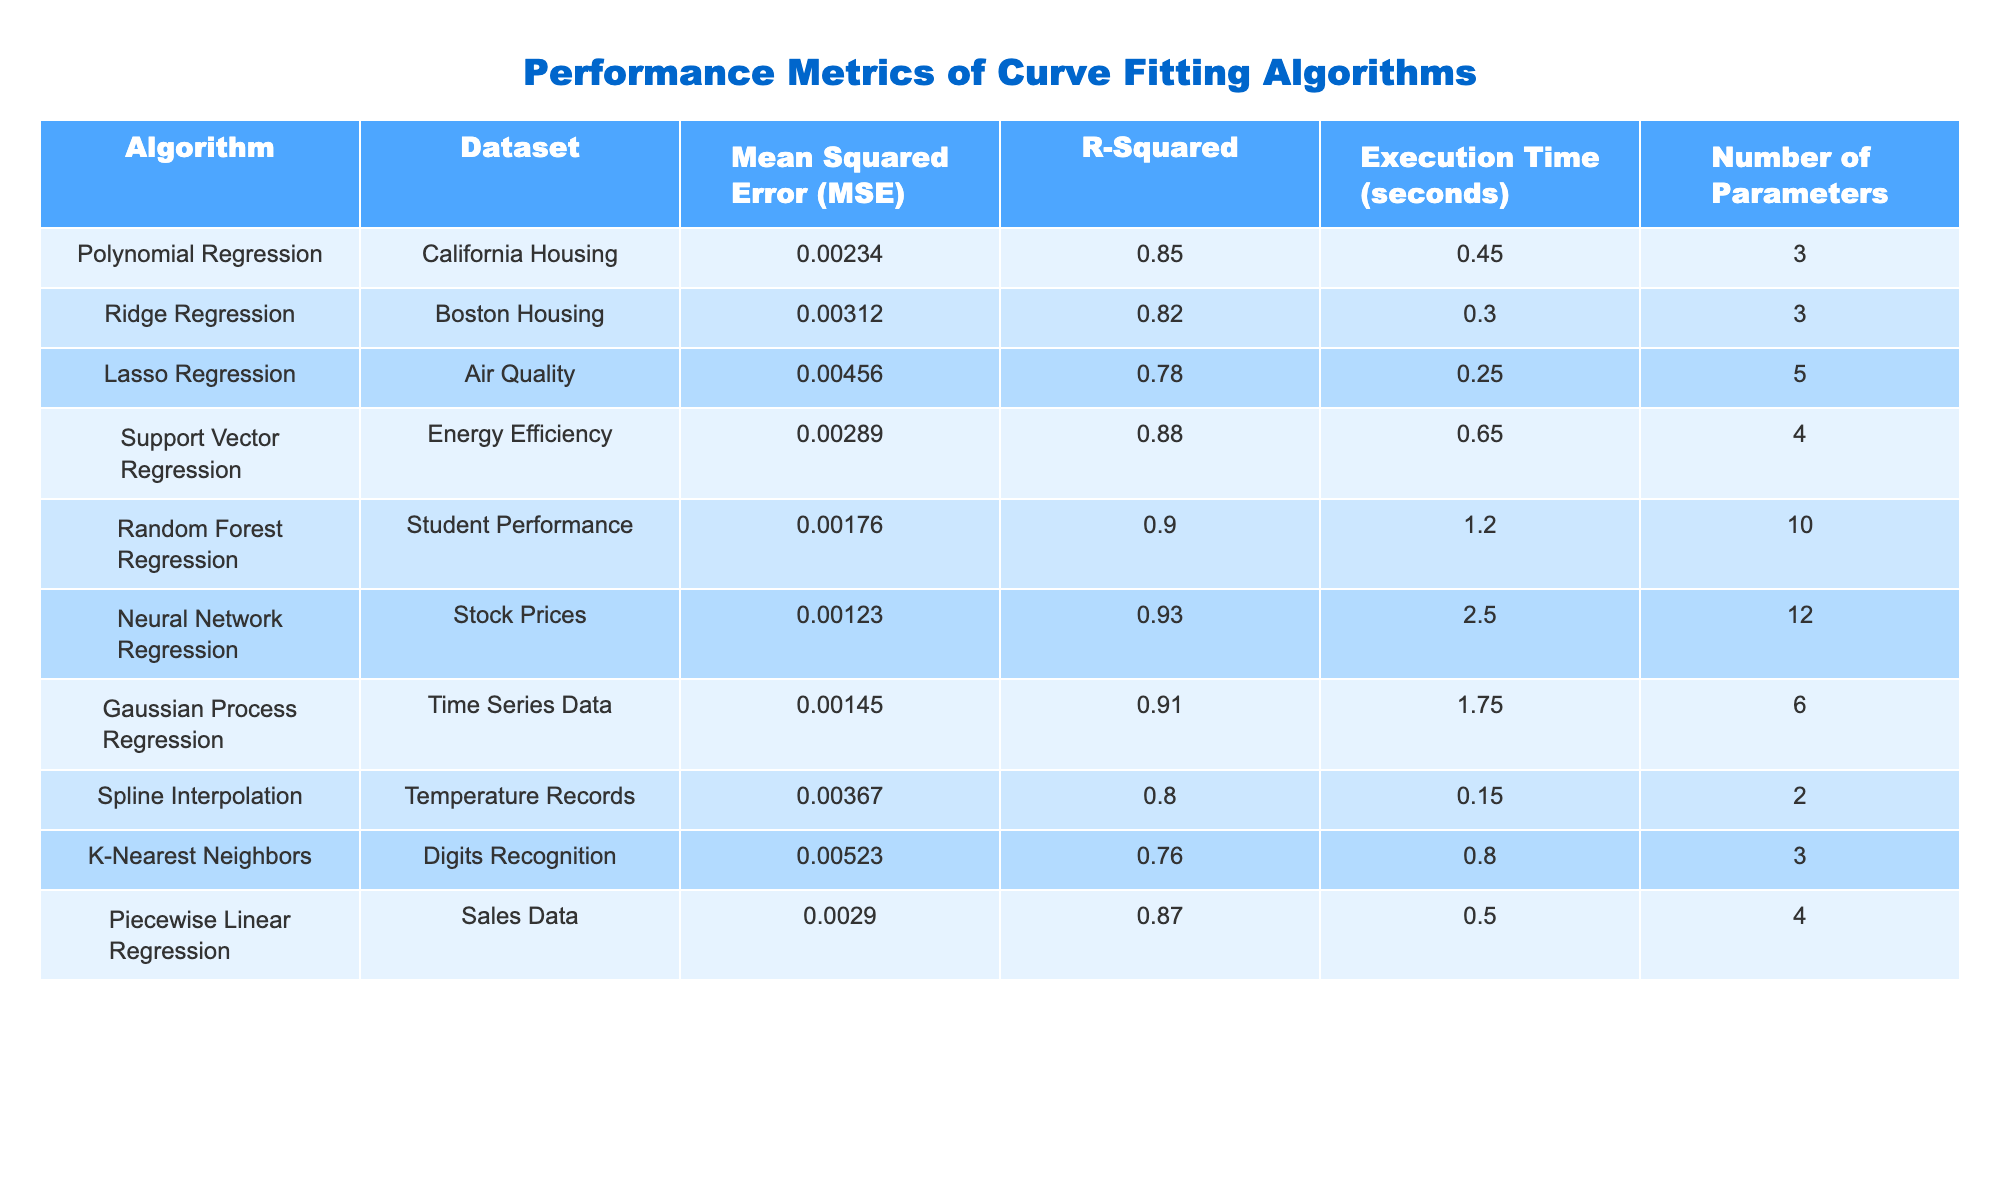What is the Mean Squared Error (MSE) for the Neural Network Regression algorithm? The table lists the MSE values for various algorithms. For Neural Network Regression, the specific value given is 0.00123.
Answer: 0.00123 Which algorithm has the highest R-Squared value? The R-Squared values can be compared across different algorithms. From the table, Neural Network Regression has the highest R-Squared value at 0.93.
Answer: 0.93 Is the execution time for Random Forest Regression greater than that of Lasso Regression? The execution time for Random Forest Regression is 1.20 seconds and for Lasso Regression it is 0.25 seconds. Since 1.20 is greater than 0.25, the statement is true.
Answer: Yes What is the average Mean Squared Error (MSE) of the algorithms listed in the table? To find the average MSE, we sum the MSE values for all algorithms: 0.00234 + 0.00312 + 0.00456 + 0.00289 + 0.00176 + 0.00123 + 0.00145 + 0.00367 + 0.00523 + 0.00290 = 0.02725. There are 10 algorithms, so the average is 0.02725 / 10 = 0.002725.
Answer: 0.002725 Which dataset used the algorithm with the least number of parameters? The table shows that Spline Interpolation uses only 2 parameters, which is the least. From the dataset column, we see that Spline Interpolation corresponds to Temperature Records.
Answer: Temperature Records How does the Mean Squared Error (MSE) of Ridge Regression compare to that of Support Vector Regression? The MSE for Ridge Regression is 0.00312, while for Support Vector Regression it is 0.00289. Therefore, Ridge Regression has a higher MSE than Support Vector Regression.
Answer: Ridge Regression has a higher MSE Which algorithm has a lower execution time than 1 second, and what are those times? From the table, the execution times for Spline Interpolation (0.15), Lasso Regression (0.25), and K-Nearest Neighbors (0.80) are all less than 1 second. These are the only algorithms fitting that criterion.
Answer: Spline Interpolation (0.15), Lasso Regression (0.25), K-Nearest Neighbors (0.80) What is the difference between the execution time of Neural Network Regression and Gaussian Process Regression? The execution time for Neural Network Regression is 2.50 seconds and for Gaussian Process Regression it is 1.75 seconds. Therefore, the difference is 2.50 - 1.75 = 0.75 seconds.
Answer: 0.75 seconds Which algorithm has the second lowest R-Squared value and what is that value? Comparing the R-Squared values, K-Nearest Neighbors has the lowest at 0.76, and the next lowest is Lasso Regression with a value of 0.78.
Answer: 0.78 